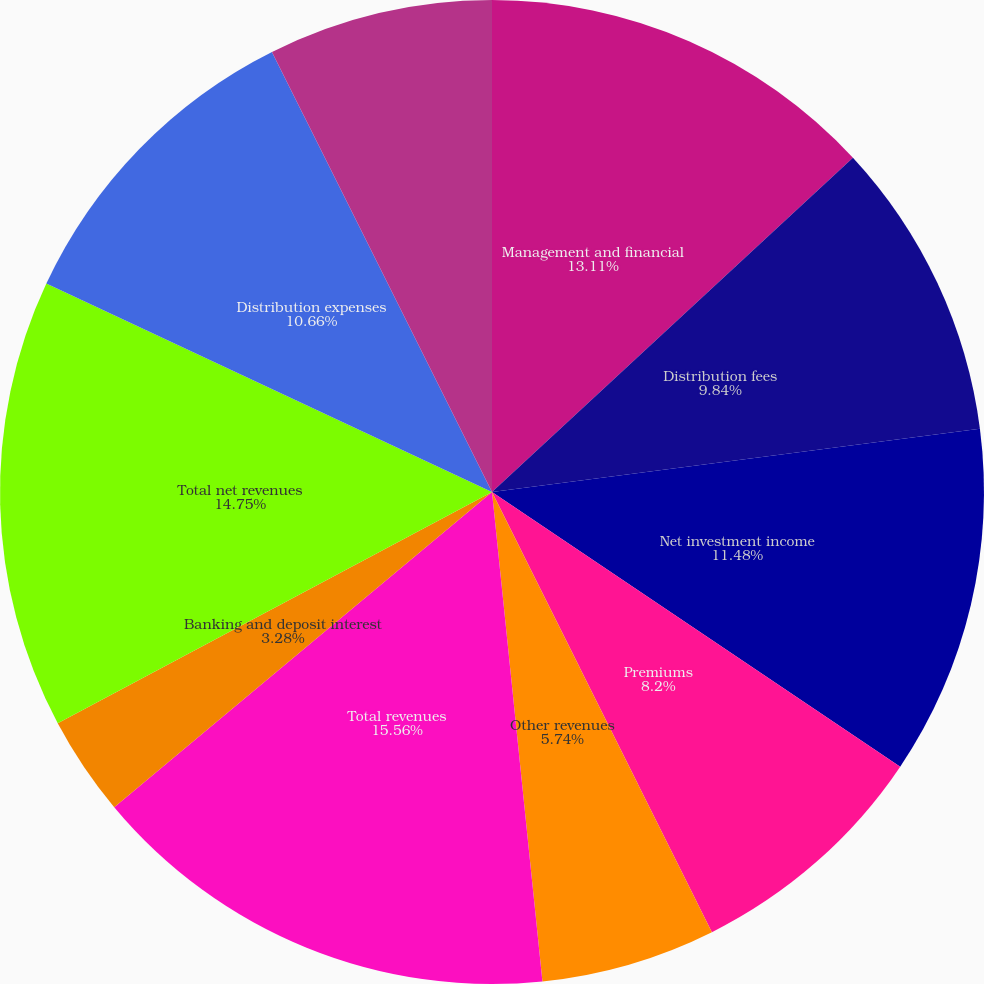Convert chart. <chart><loc_0><loc_0><loc_500><loc_500><pie_chart><fcel>Management and financial<fcel>Distribution fees<fcel>Net investment income<fcel>Premiums<fcel>Other revenues<fcel>Total revenues<fcel>Banking and deposit interest<fcel>Total net revenues<fcel>Distribution expenses<fcel>Interest credited to fixed<nl><fcel>13.11%<fcel>9.84%<fcel>11.48%<fcel>8.2%<fcel>5.74%<fcel>15.57%<fcel>3.28%<fcel>14.75%<fcel>10.66%<fcel>7.38%<nl></chart> 